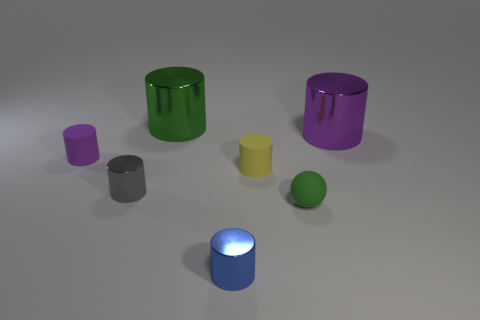There is a green object in front of the purple cylinder left of the small yellow matte thing; what is it made of? The green object positioned in front of the purple cylinder to the left of the small yellow matte object appears to be a smaller, shiny sphere. Given its visual attributes and context within this collection of geometric shapes, it is likely designed to represent a sphere made of rubber or plastic, which is common in artificial renderings to simulate reflective properties and tactile textures. 